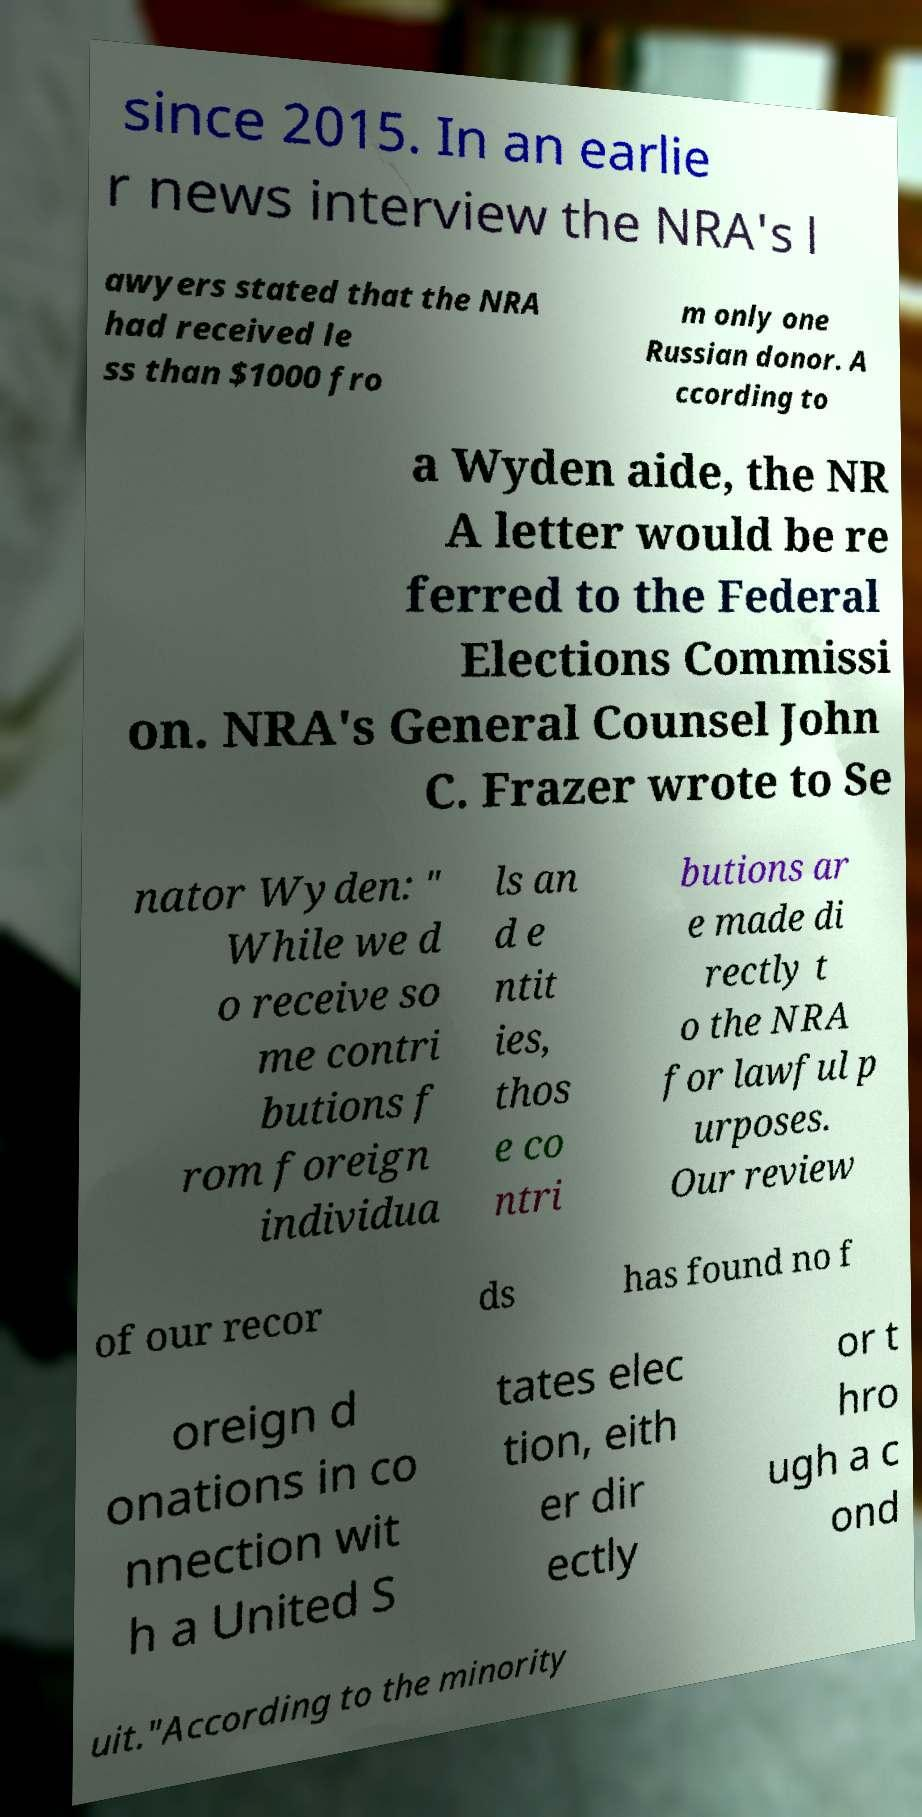Could you assist in decoding the text presented in this image and type it out clearly? since 2015. In an earlie r news interview the NRA's l awyers stated that the NRA had received le ss than $1000 fro m only one Russian donor. A ccording to a Wyden aide, the NR A letter would be re ferred to the Federal Elections Commissi on. NRA's General Counsel John C. Frazer wrote to Se nator Wyden: " While we d o receive so me contri butions f rom foreign individua ls an d e ntit ies, thos e co ntri butions ar e made di rectly t o the NRA for lawful p urposes. Our review of our recor ds has found no f oreign d onations in co nnection wit h a United S tates elec tion, eith er dir ectly or t hro ugh a c ond uit."According to the minority 